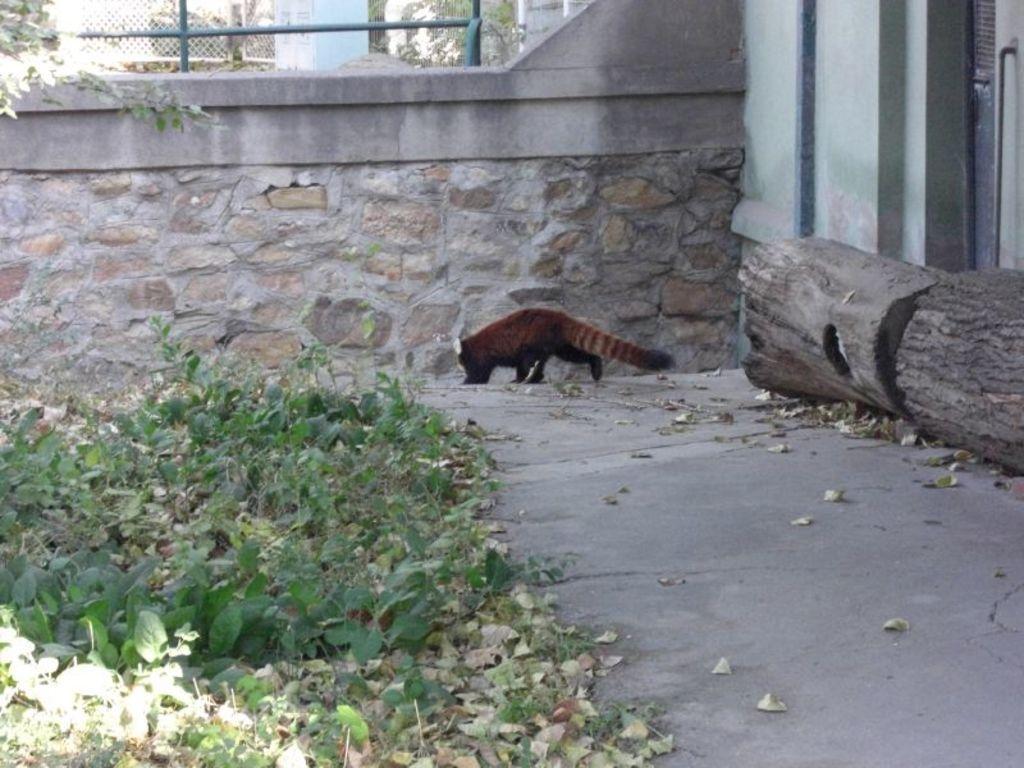How would you summarize this image in a sentence or two? In this image we can see an animal on the ground. We can also see some plants, dried leaves, a wooden log, some poles, a fence and a wall. 